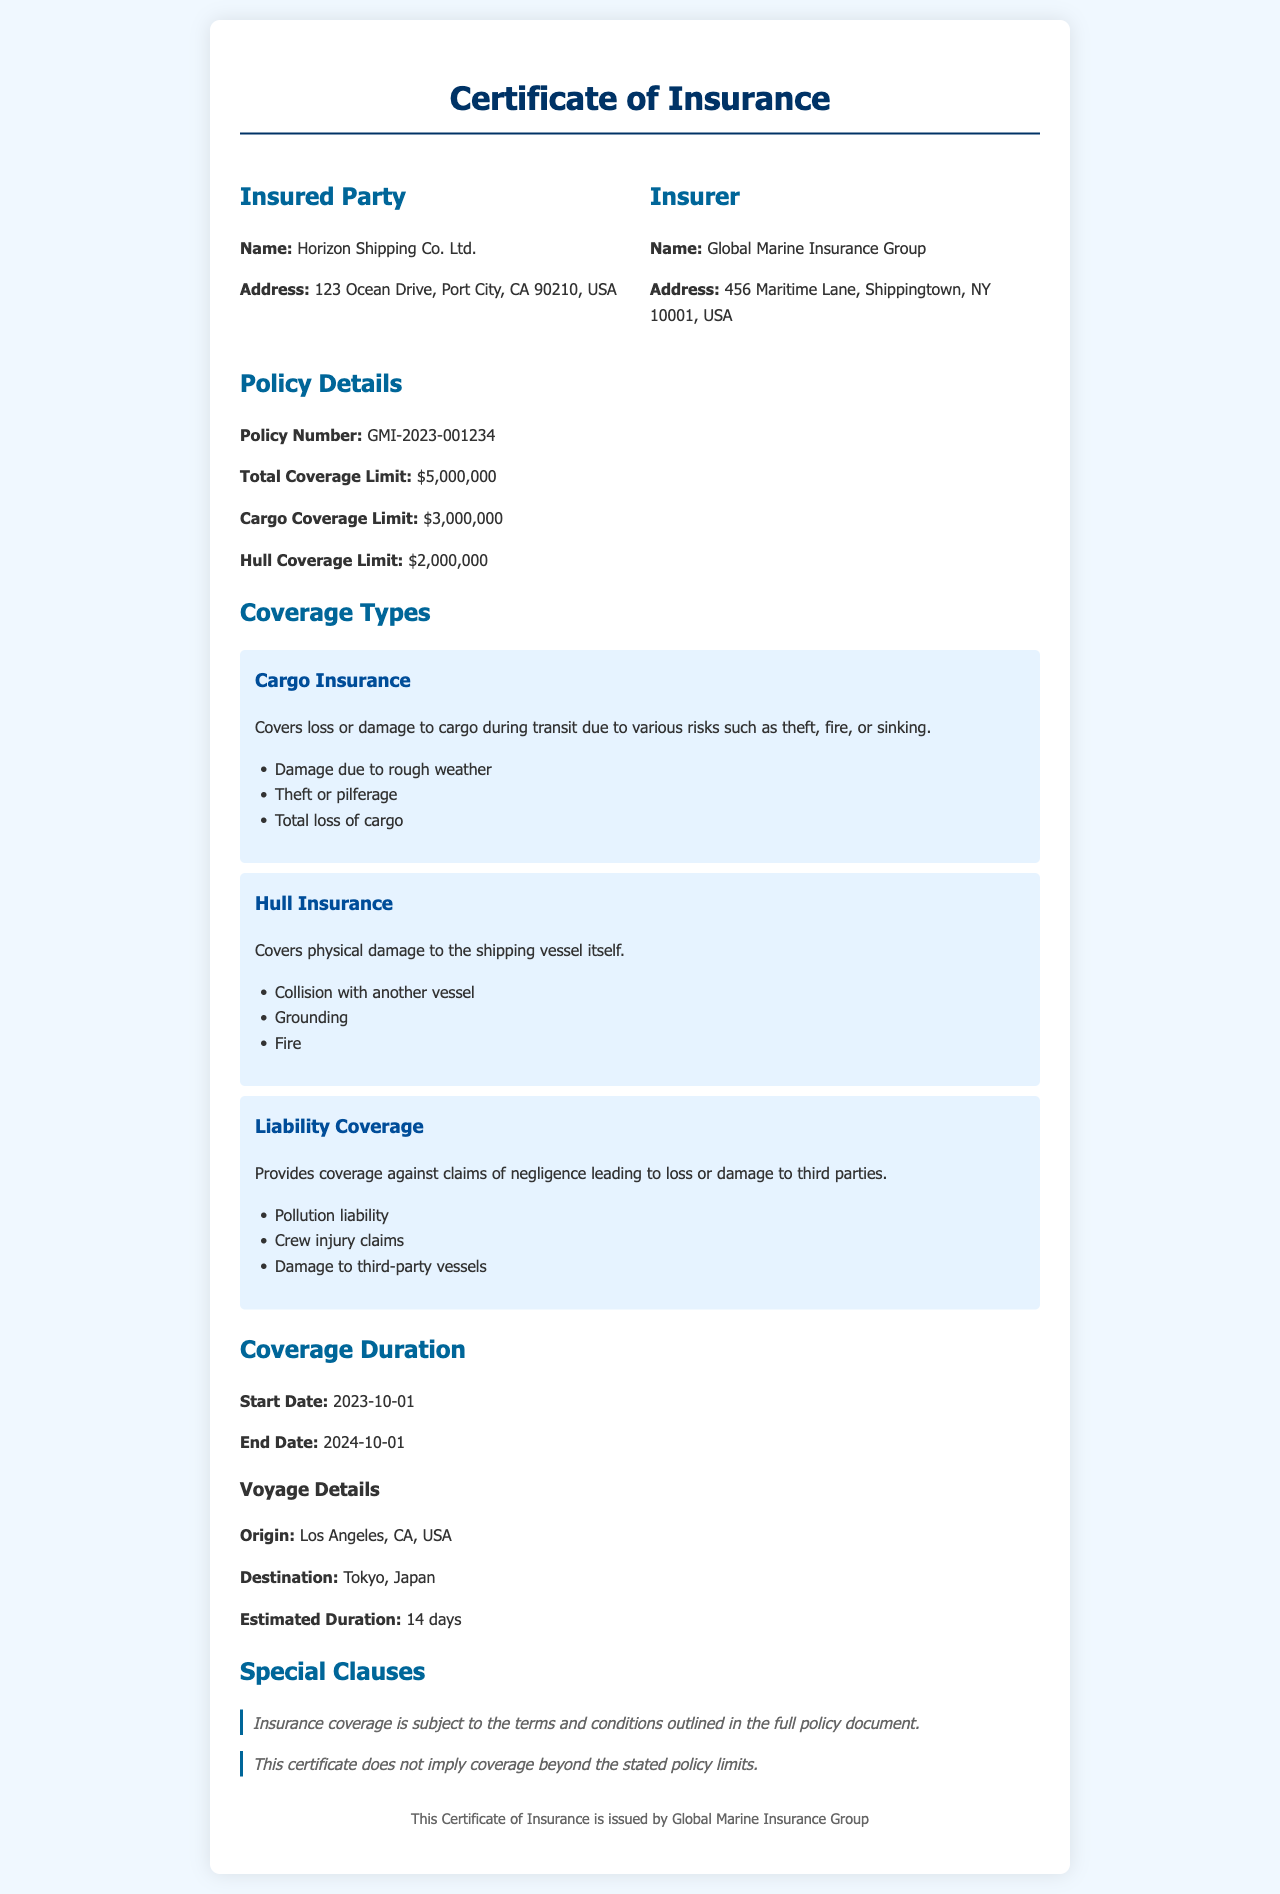What is the policy number? The policy number is provided in the policy details section of the document as GMI-2023-001234.
Answer: GMI-2023-001234 What is the total coverage limit? The total coverage limit is mentioned in the policy details section as $5,000,000.
Answer: $5,000,000 What is the address of the insured party? The address of the insured party, Horizon Shipping Co. Ltd., is detailed in the insured party section as 123 Ocean Drive, Port City, CA 90210, USA.
Answer: 123 Ocean Drive, Port City, CA 90210, USA What type of insurance covers loss or damage to cargo? The document specifies "Cargo Insurance" as the type that covers loss or damage to cargo during transit.
Answer: Cargo Insurance When does the coverage start? According to the coverage duration section, the start date is listed as 2023-10-01.
Answer: 2023-10-01 What is the destination of the shipping voyage? The destination of the shipping voyage is specified in the voyage details part of the document as Tokyo, Japan.
Answer: Tokyo, Japan What is the liability coverage for? The document indicates that liability coverage provides coverage against claims of negligence leading to loss or damage to third parties.
Answer: Claims of negligence What special clause is mentioned regarding coverage limits? A special clause states that the certificate does not imply coverage beyond the stated policy limits.
Answer: Does not imply coverage beyond the stated policy limits How long is the estimated duration of the voyage? The estimated duration of the voyage is provided in the voyage details section as 14 days.
Answer: 14 days 